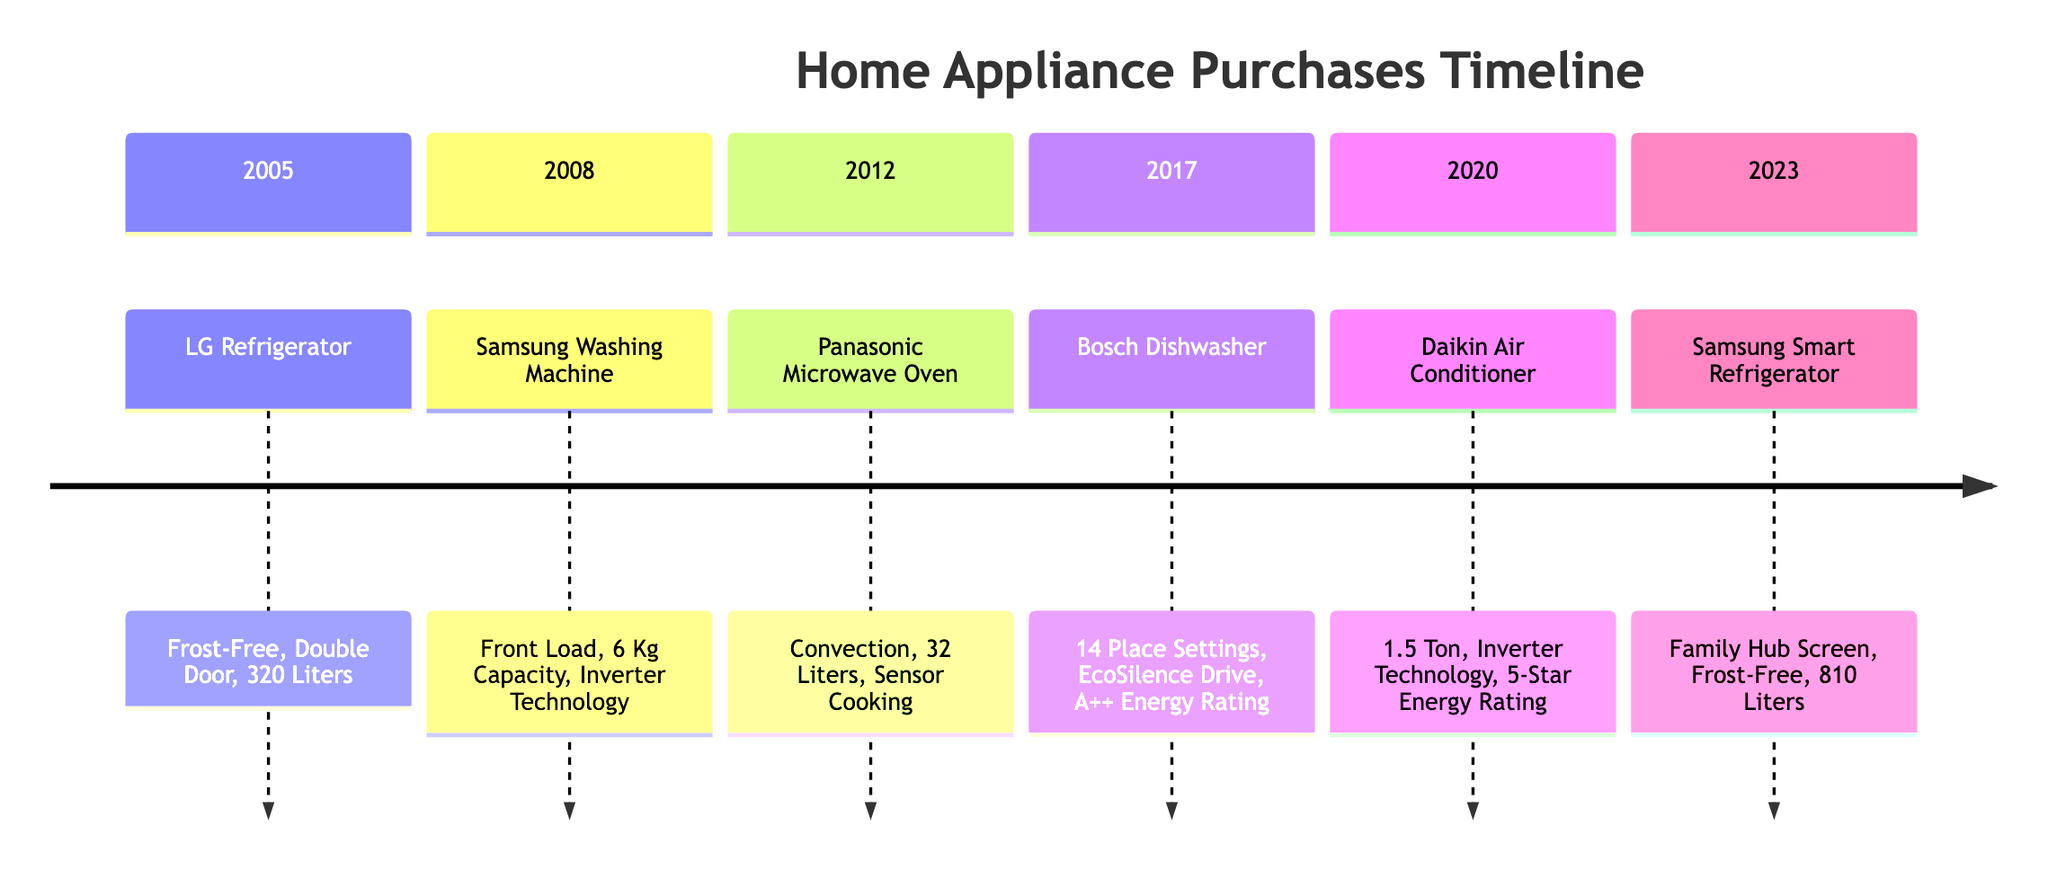What year was the Dishwasher purchased? The timeline indicates that the Dishwasher was purchased in 2017. This information is found under the section for that year.
Answer: 2017 Which brand produced the Air Conditioner? The Air Conditioner listed in the timeline is produced by Daikin, as indicated next to the appliance under the year 2020.
Answer: Daikin What is the capacity of the LG Refrigerator? The LG Refrigerator, purchased in 2005, is specified to have a capacity of 320 Liters. This detail is included in the key features for that appliance.
Answer: 320 Liters How many place settings does the Bosch Dishwasher accommodate? The Bosch Dishwasher can accommodate 14 Place Settings, which is explicitly mentioned in the key features for the 2017 entry on the timeline.
Answer: 14 Place Settings Which appliance was bought in 2023? The timeline shows that the Smart Refrigerator was purchased in 2023, as stated in the section for that year.
Answer: Smart Refrigerator What is a key feature of the Panasonic Microwave Oven? One of the key features of the Panasonic Microwave Oven, purchased in 2012, is "Sensor Cooking", which is one of the three features listed for that appliance.
Answer: Sensor Cooking Which appliance has the highest capacity? The Smart Refrigerator, purchased in 2023, has the highest capacity at 810 Liters, which is indicated in its key features.
Answer: 810 Liters What type of washing machine was purchased in 2008? The washing machine purchased in 2008 is a Front Load type, as noted in the details for that appliance on the timeline.
Answer: Front Load 